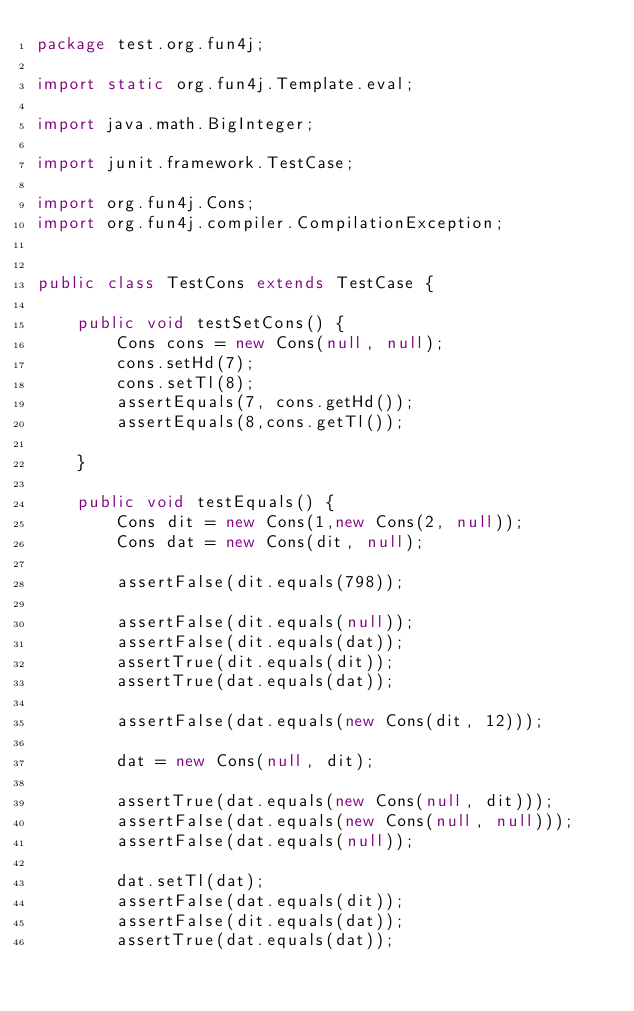Convert code to text. <code><loc_0><loc_0><loc_500><loc_500><_Java_>package test.org.fun4j;

import static org.fun4j.Template.eval;

import java.math.BigInteger;

import junit.framework.TestCase;

import org.fun4j.Cons;
import org.fun4j.compiler.CompilationException;


public class TestCons extends TestCase {

    public void testSetCons() {
        Cons cons = new Cons(null, null);
        cons.setHd(7);
        cons.setTl(8);
        assertEquals(7, cons.getHd());
        assertEquals(8,cons.getTl());
        
    }
    
    public void testEquals() {
        Cons dit = new Cons(1,new Cons(2, null));
        Cons dat = new Cons(dit, null);
        
        assertFalse(dit.equals(798));
        
        assertFalse(dit.equals(null));
        assertFalse(dit.equals(dat));
        assertTrue(dit.equals(dit));
        assertTrue(dat.equals(dat));
        
        assertFalse(dat.equals(new Cons(dit, 12)));
        
        dat = new Cons(null, dit);
        
        assertTrue(dat.equals(new Cons(null, dit)));
        assertFalse(dat.equals(new Cons(null, null)));
        assertFalse(dat.equals(null));
        
        dat.setTl(dat);
        assertFalse(dat.equals(dit));
        assertFalse(dit.equals(dat));
        assertTrue(dat.equals(dat));
        </code> 